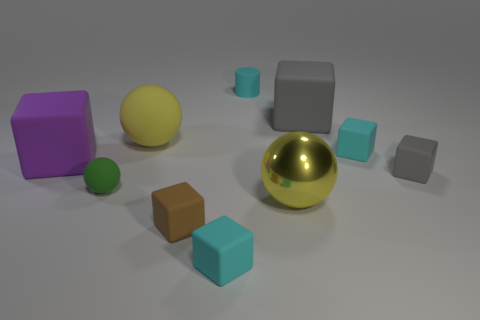Subtract all yellow spheres. How many gray cubes are left? 2 Subtract all brown cubes. How many cubes are left? 5 Subtract all big spheres. How many spheres are left? 1 Subtract 1 blocks. How many blocks are left? 5 Subtract all spheres. How many objects are left? 7 Add 4 cyan rubber cubes. How many cyan rubber cubes exist? 6 Subtract 0 gray cylinders. How many objects are left? 10 Subtract all gray cubes. Subtract all blue cylinders. How many cubes are left? 4 Subtract all tiny blue metallic cylinders. Subtract all cyan matte things. How many objects are left? 7 Add 6 tiny brown matte blocks. How many tiny brown matte blocks are left? 7 